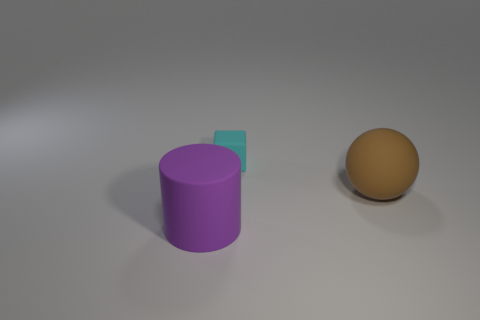Add 1 red cubes. How many objects exist? 4 Subtract all balls. How many objects are left? 2 Subtract all big matte things. Subtract all tiny cyan metal things. How many objects are left? 1 Add 1 big brown rubber balls. How many big brown rubber balls are left? 2 Add 1 rubber cubes. How many rubber cubes exist? 2 Subtract 0 yellow balls. How many objects are left? 3 